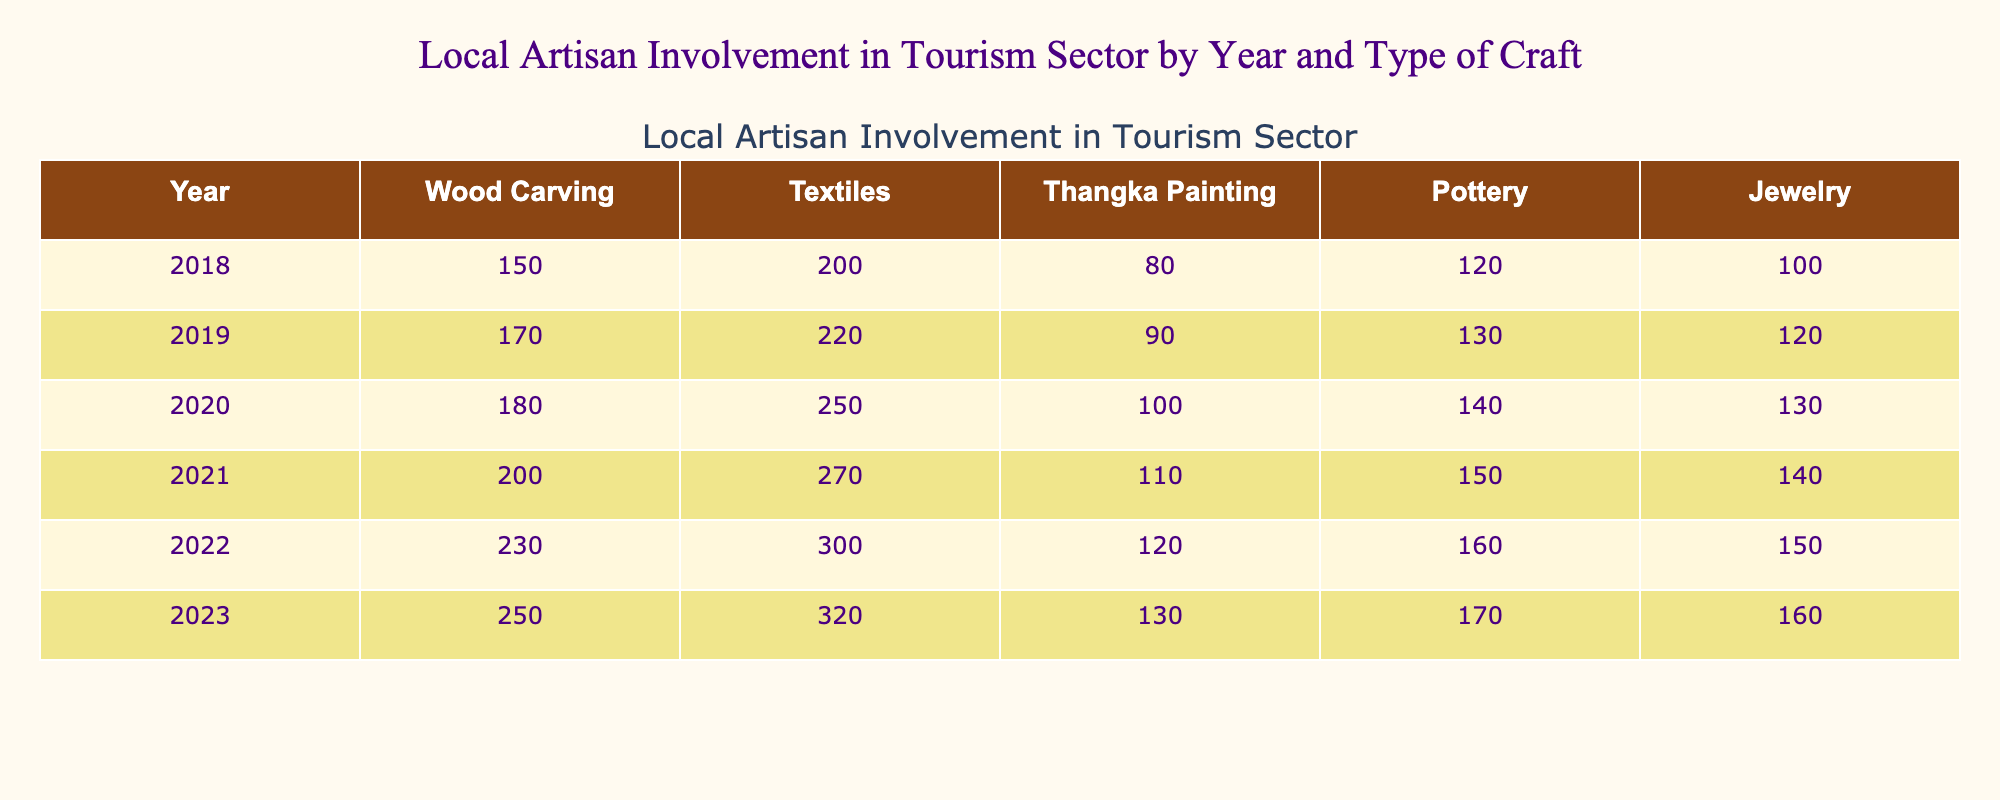What was the number of artisans involved in Wood Carving in 2020? According to the table, the number of artisans involved in Wood Carving in 2020 is directly listed as 180.
Answer: 180 In which year did Jewelry have the highest involvement? By comparing the values for Jewelry across the years in the table, it shows a consistent increase, reaching the highest involvement of 160 in 2023.
Answer: 2023 What is the difference in the number of artisans involved in Thangka Painting between 2018 and 2023? In 2018, there were 80 artisans involved in Thangka Painting, and in 2023, there were 130. The difference is calculated as 130 - 80 = 50.
Answer: 50 What is the total number of artisans involved in all crafts for the year 2021? The values for 2021 are: Wood Carving (200), Textiles (270), Thangka Painting (110), Pottery (150), and Jewelry (140). Adding these: 200 + 270 + 110 + 150 + 140 = 870.
Answer: 870 Which craft saw the largest increase in artisan involvement from 2018 to 2023? The increase for each craft from 2018 to 2023 is as follows: Wood Carving (+100), Textiles (+120), Thangka Painting (+50), Pottery (+50), and Jewelry (+60). The largest increase is for Textiles, which saw an increase of 120 artisans.
Answer: Textiles What was the average number of artisans involved in Pottery from 2018 to 2023? The values for Pottery across the years are: 120, 130, 140, 150, 160, and 170. Adding these gives 120 + 130 + 140 + 150 + 160 + 170 = 970. There are 6 years, so the average is 970 / 6 = 161.67, which rounds to approximately 162.
Answer: 162 Is there a year with less than 100 artisans involved in Textile crafts? By inspecting the table, it is evident that the number of artisans involved in Textiles starts at 200 in 2018 and increases each subsequent year, meaning there is no year with less than 100 artisans involved.
Answer: No If we combine the number of artisans involved in Wood Carving and Pottery for 2022, how many artisans were involved? In 2022, there were 230 artisans in Wood Carving and 160 in Pottery. Adding these gives 230 + 160 = 390 artisans involved in both crafts together.
Answer: 390 What pattern can you observe in the involvement of artisans in Textiles from 2018 to 2023? The involvement of artisans in Textiles shows a consistent upward trend, increasing each year from 200 in 2018 to 320 in 2023, indicating growing interest or demand in this craft.
Answer: Consistent increase Which craft had the least involvement in 2019? By reviewing the data for 2019, the numbers are as follows: Wood Carving (170), Textiles (220), Thangka Painting (90), Pottery (130), and Jewelry (120). The least involvement is 90 in Thangka Painting.
Answer: Thangka Painting 